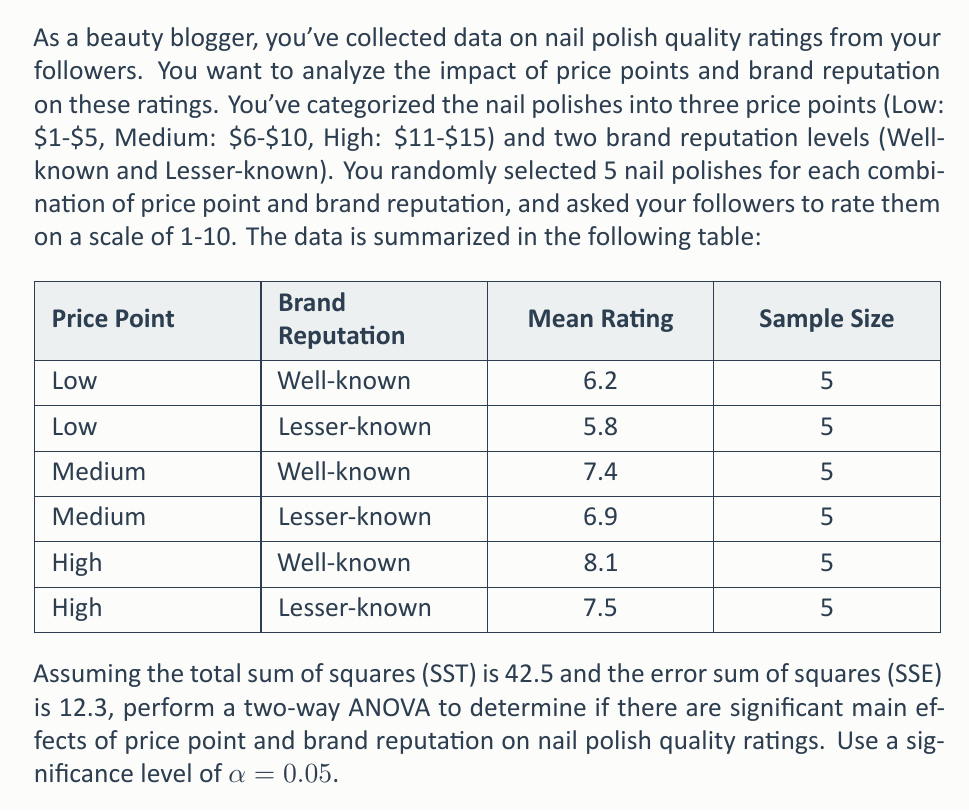Could you help me with this problem? To perform a two-way ANOVA, we need to follow these steps:

1. Calculate degrees of freedom (df):
   - Total df = $n - 1 = (3 * 2 * 5) - 1 = 29$
   - Price Point df = $a - 1 = 3 - 1 = 2$
   - Brand Reputation df = $b - 1 = 2 - 1 = 1$
   - Interaction df = $(a - 1)(b - 1) = 2 * 1 = 2$
   - Error df = $ab(n - 1) = 3 * 2 * (5 - 1) = 24$

2. Calculate Sum of Squares:
   - SST (given) = 42.5
   - SSE (given) = 12.3
   - SSModel = SST - SSE = 42.5 - 12.3 = 30.2

3. Calculate Mean Squares:
   - MSE = SSE / Error df = 12.3 / 24 = 0.5125

4. Calculate F-statistics:
   - For Price Point: $F_A = \frac{MS_A}{MSE}$
   - For Brand Reputation: $F_B = \frac{MS_B}{MSE}$
   - For Interaction: $F_{AB} = \frac{MS_{AB}}{MSE}$

5. Compare F-statistics with critical F-values:
   - For Price Point: $F_{crit}(2, 24) = 3.40$ at α = 0.05
   - For Brand Reputation: $F_{crit}(1, 24) = 4.26$ at α = 0.05
   - For Interaction: $F_{crit}(2, 24) = 3.40$ at α = 0.05

Now, let's calculate the sum of squares for each factor:

SSA (Price Point) = $5 * 2 * [(6.2 + 5.8 - 7)^2 + (7.4 + 6.9 - 7)^2 + (8.1 + 7.5 - 7)^2] / 2 = 24.15$

SSB (Brand Reputation) = $5 * 3 * [(6.2 + 7.4 + 8.1 - 7)^2 + (5.8 + 6.9 + 7.5 - 7)^2] / 6 = 3.75$

SSAB (Interaction) = SSModel - SSA - SSB = 30.2 - 24.15 - 3.75 = 2.3

Now we can calculate the mean squares:

MSA = SSA / dfA = 24.15 / 2 = 12.075
MSB = SSB / dfB = 3.75 / 1 = 3.75
MSAB = SSAB / dfAB = 2.3 / 2 = 1.15

Finally, we can calculate the F-statistics:

$F_A = \frac{MS_A}{MSE} = \frac{12.075}{0.5125} = 23.56$
$F_B = \frac{MS_B}{MSE} = \frac{3.75}{0.5125} = 7.32$
$F_{AB} = \frac{MS_{AB}}{MSE} = \frac{1.15}{0.5125} = 2.24$

Comparing these F-statistics with the critical F-values:

- For Price Point: 23.56 > 3.40, so there is a significant main effect of price point.
- For Brand Reputation: 7.32 > 4.26, so there is a significant main effect of brand reputation.
- For Interaction: 2.24 < 3.40, so there is no significant interaction effect.
Answer: There is a significant main effect of price point (F(2, 24) = 23.56, p < 0.05) and a significant main effect of brand reputation (F(1, 24) = 7.32, p < 0.05) on nail polish quality ratings. However, there is no significant interaction effect between price point and brand reputation (F(2, 24) = 2.24, p > 0.05). 